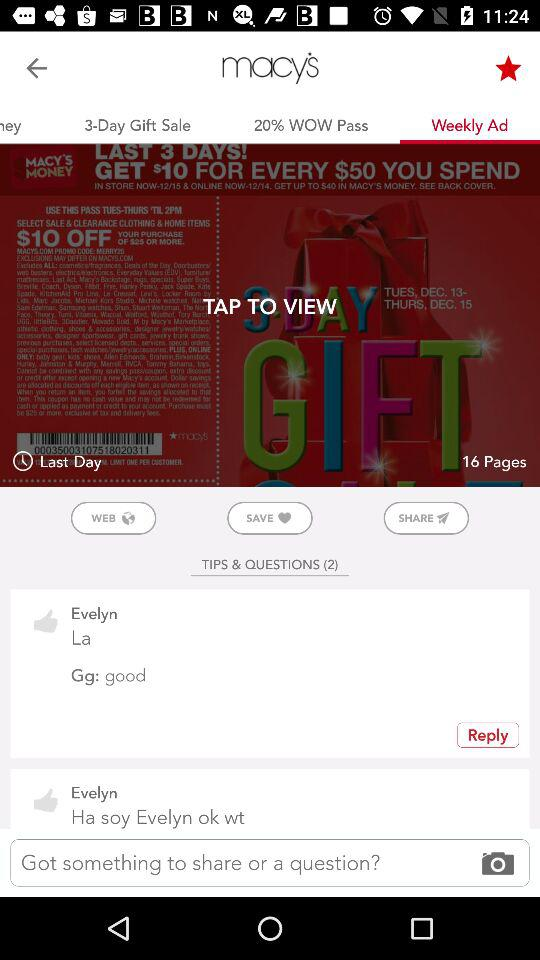Where is Macy's located?
When the provided information is insufficient, respond with <no answer>. <no answer> 